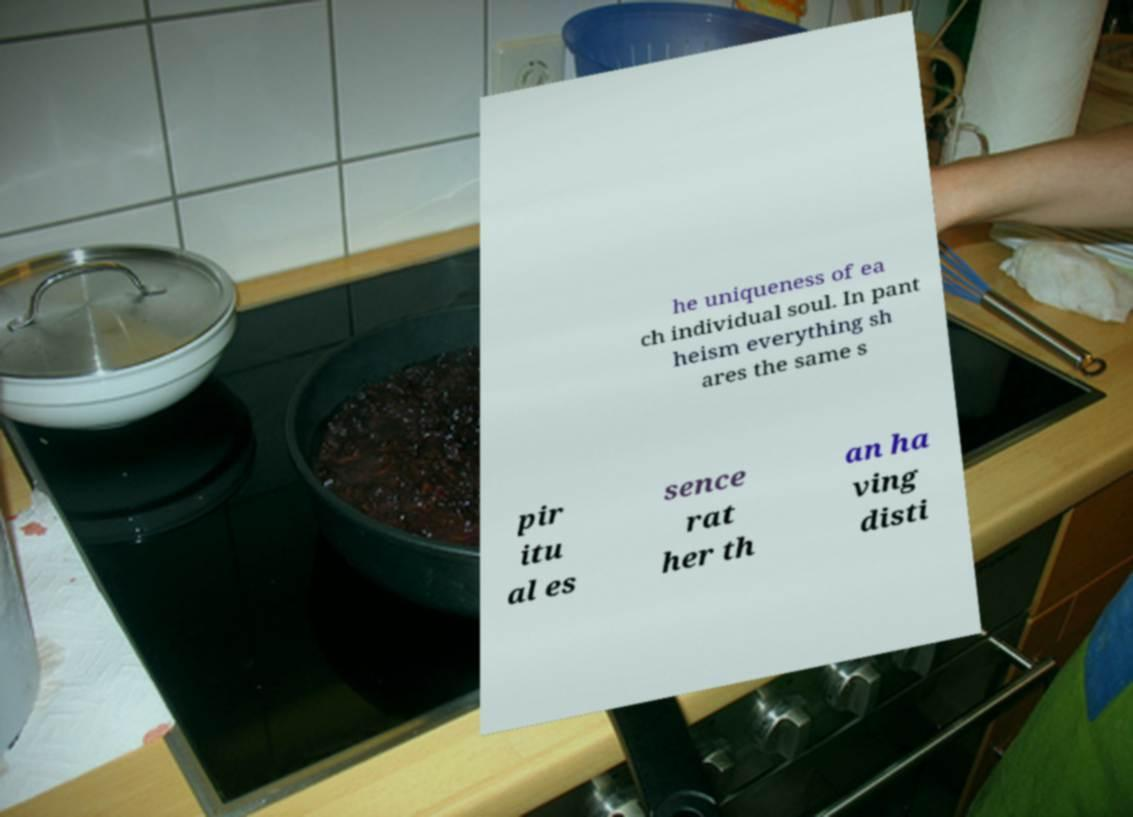Please identify and transcribe the text found in this image. he uniqueness of ea ch individual soul. In pant heism everything sh ares the same s pir itu al es sence rat her th an ha ving disti 